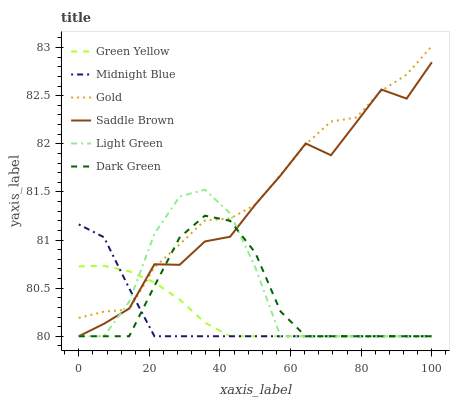Does Midnight Blue have the minimum area under the curve?
Answer yes or no. Yes. Does Gold have the maximum area under the curve?
Answer yes or no. Yes. Does Light Green have the minimum area under the curve?
Answer yes or no. No. Does Light Green have the maximum area under the curve?
Answer yes or no. No. Is Green Yellow the smoothest?
Answer yes or no. Yes. Is Saddle Brown the roughest?
Answer yes or no. Yes. Is Gold the smoothest?
Answer yes or no. No. Is Gold the roughest?
Answer yes or no. No. Does Midnight Blue have the lowest value?
Answer yes or no. Yes. Does Gold have the lowest value?
Answer yes or no. No. Does Gold have the highest value?
Answer yes or no. Yes. Does Light Green have the highest value?
Answer yes or no. No. Does Dark Green intersect Gold?
Answer yes or no. Yes. Is Dark Green less than Gold?
Answer yes or no. No. Is Dark Green greater than Gold?
Answer yes or no. No. 